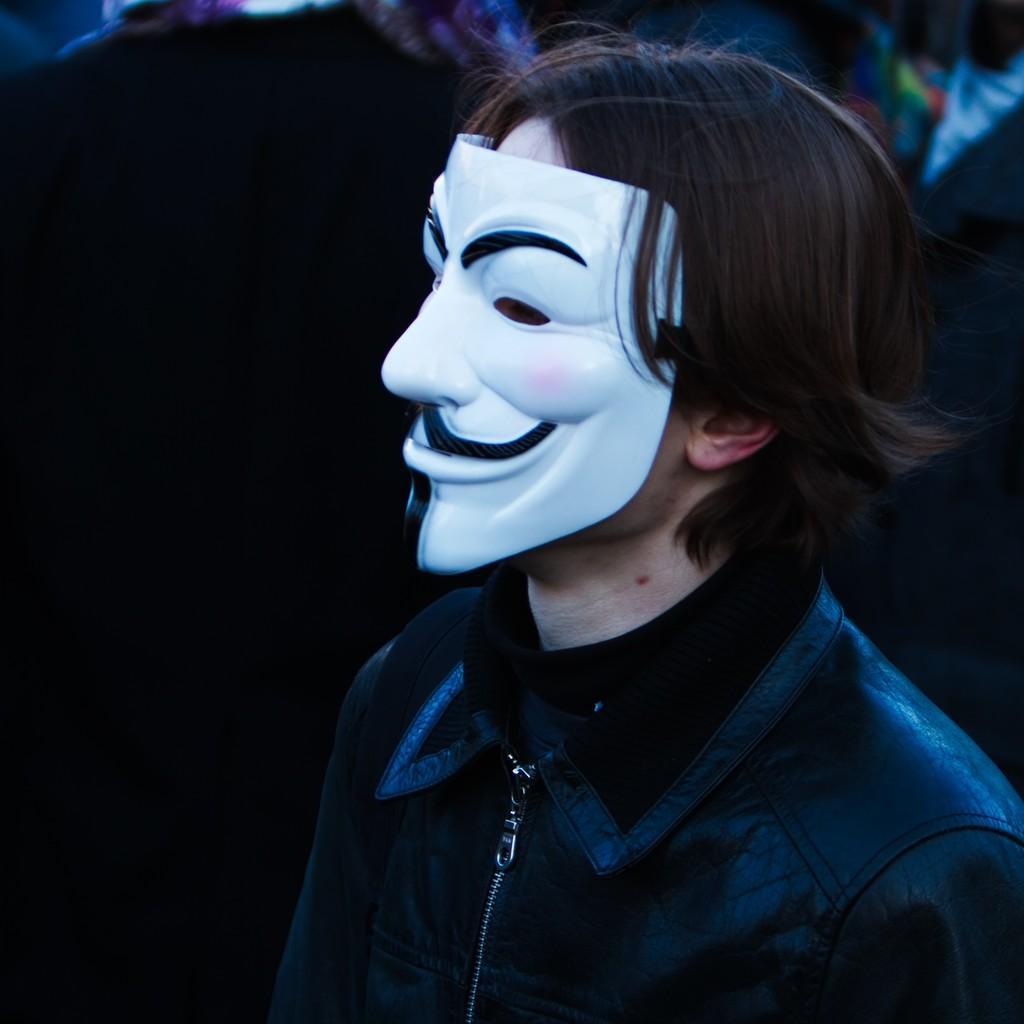Please provide a concise description of this image. In this picture I can see a person with a mask, and there is blur background. 